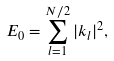Convert formula to latex. <formula><loc_0><loc_0><loc_500><loc_500>E _ { 0 } = \sum _ { l = 1 } ^ { N / 2 } | { k } _ { l } | ^ { 2 } ,</formula> 